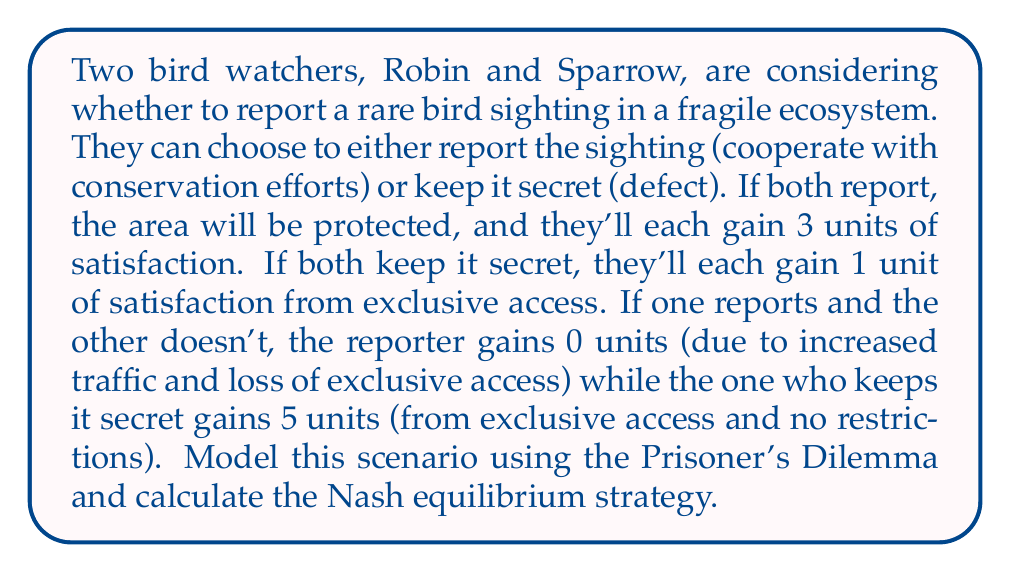Provide a solution to this math problem. Let's approach this step-by-step:

1) First, we need to set up the payoff matrix for this Prisoner's Dilemma:

   [asy]
   unitsize(1cm);
   
   draw((0,0)--(6,0)--(6,4)--(0,4)--cycle);
   draw((3,0)--(3,4));
   draw((0,2)--(6,2));
   
   label("Robin / Sparrow", (1.5,3.5));
   label("Report", (1.5,2.5));
   label("Keep Secret", (1.5,0.5));
   
   label("Report", (4.5,3.5));
   label("Keep Secret", (4.5,2.5));
   
   label("(3, 3)", (4.5,2.5));
   label("(0, 5)", (4.5,0.5));
   label("(5, 0)", (1.5,2.5));
   label("(1, 1)", (1.5,0.5));
   [/asy]

2) To find the Nash equilibrium, we need to determine the best response for each player given the other player's strategy.

3) For Robin:
   - If Sparrow reports, Robin's best response is to keep secret (5 > 3)
   - If Sparrow keeps secret, Robin's best response is to keep secret (1 > 0)

4) For Sparrow:
   - If Robin reports, Sparrow's best response is to keep secret (5 > 3)
   - If Robin keeps secret, Sparrow's best response is to keep secret (1 > 0)

5) The Nash equilibrium is where both players are playing their best response to each other's strategy. In this case, it's when both keep the sighting secret.

6) We can also verify this using the concept of dominant strategy:
   For both players, keeping the sighting secret always yields a higher payoff regardless of what the other player does. Therefore, keeping secret is the dominant strategy for both players.

7) In game theory terms, (Keep Secret, Keep Secret) is a dominant strategy equilibrium, which is also a Nash equilibrium.
Answer: The Nash equilibrium strategy is for both bird watchers to keep the sighting secret, resulting in payoffs of (1, 1). 